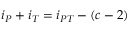Convert formula to latex. <formula><loc_0><loc_0><loc_500><loc_500>i _ { P } + i _ { T } = i _ { P T } - ( c - 2 )</formula> 